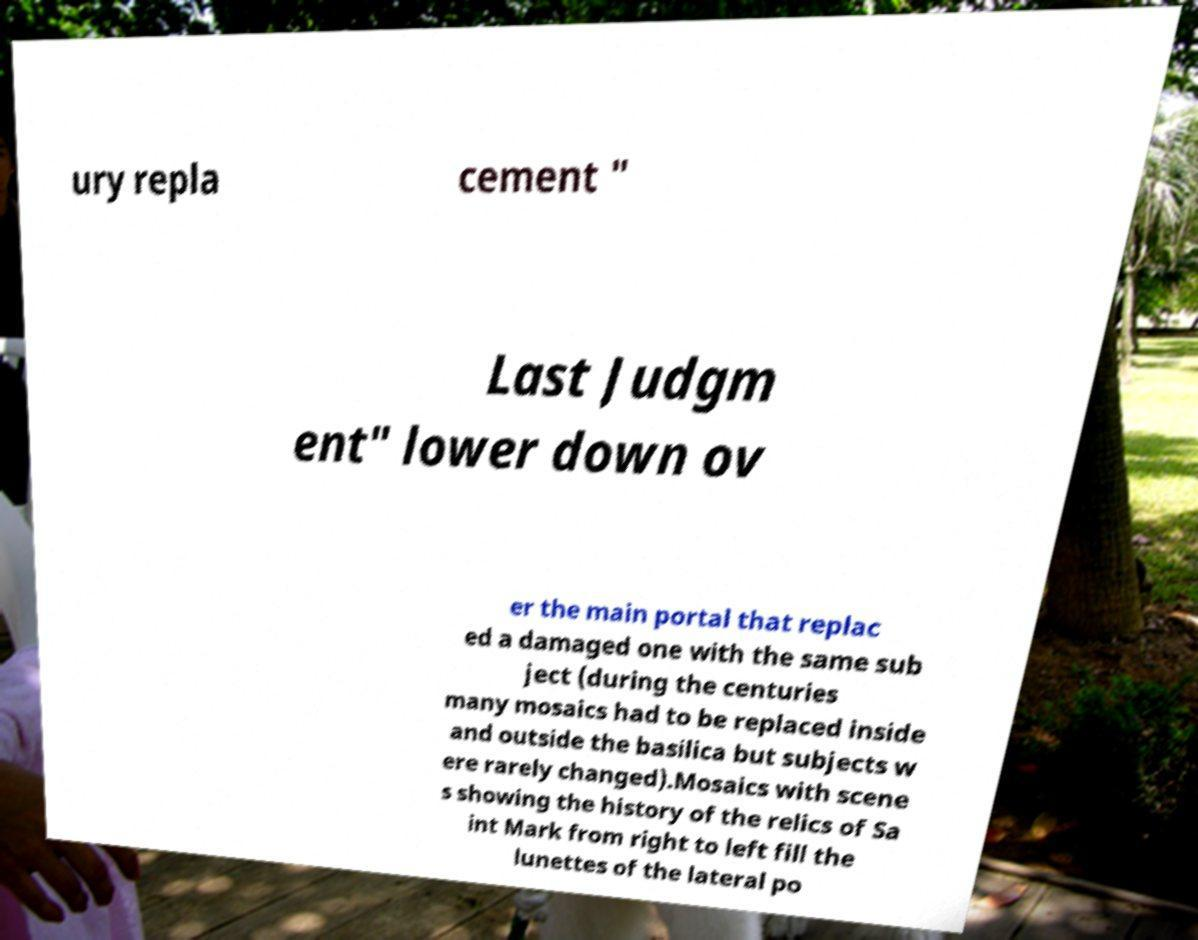Please read and relay the text visible in this image. What does it say? ury repla cement " Last Judgm ent" lower down ov er the main portal that replac ed a damaged one with the same sub ject (during the centuries many mosaics had to be replaced inside and outside the basilica but subjects w ere rarely changed).Mosaics with scene s showing the history of the relics of Sa int Mark from right to left fill the lunettes of the lateral po 